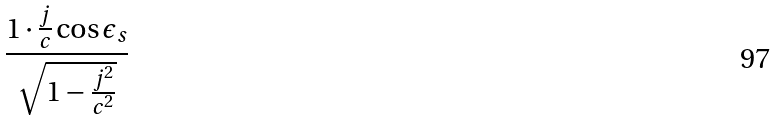<formula> <loc_0><loc_0><loc_500><loc_500>\frac { 1 \cdot \frac { j } { c } \cos \epsilon _ { s } } { \sqrt { 1 - \frac { j ^ { 2 } } { c ^ { 2 } } } }</formula> 